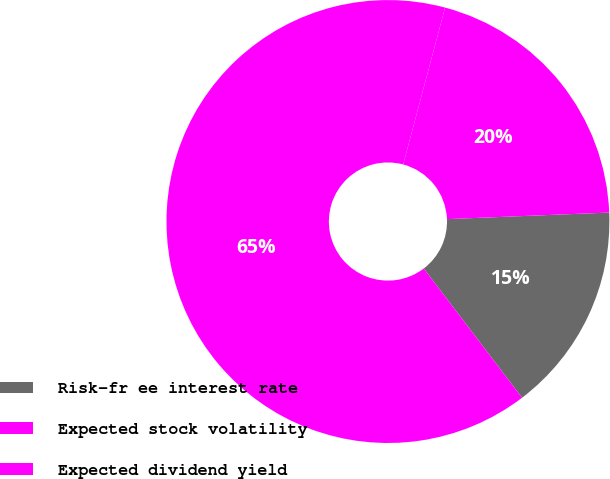Convert chart to OTSL. <chart><loc_0><loc_0><loc_500><loc_500><pie_chart><fcel>Risk-fr ee interest rate<fcel>Expected stock volatility<fcel>Expected dividend yield<nl><fcel>15.29%<fcel>64.51%<fcel>20.2%<nl></chart> 